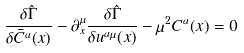Convert formula to latex. <formula><loc_0><loc_0><loc_500><loc_500>\frac { \delta \hat { \Gamma } } { \delta \bar { C } ^ { a } ( x ) } - \partial _ { x } ^ { \mu } \frac { \delta \hat { \Gamma } } { \delta u ^ { a \mu } ( x ) } - \mu ^ { 2 } C ^ { a } ( x ) = 0</formula> 